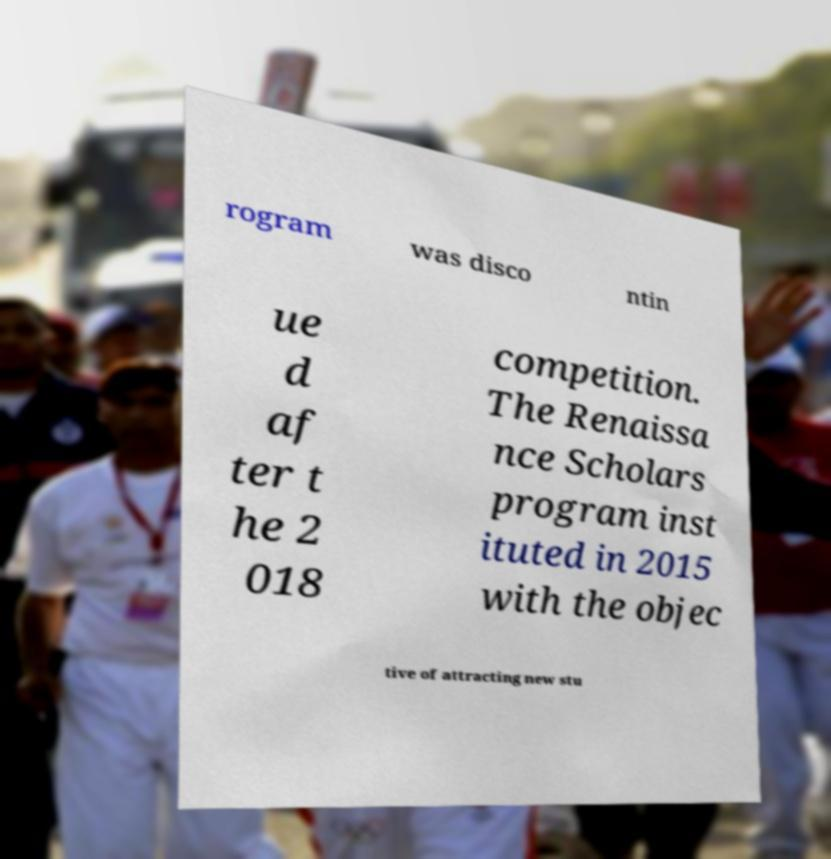Please read and relay the text visible in this image. What does it say? rogram was disco ntin ue d af ter t he 2 018 competition. The Renaissa nce Scholars program inst ituted in 2015 with the objec tive of attracting new stu 